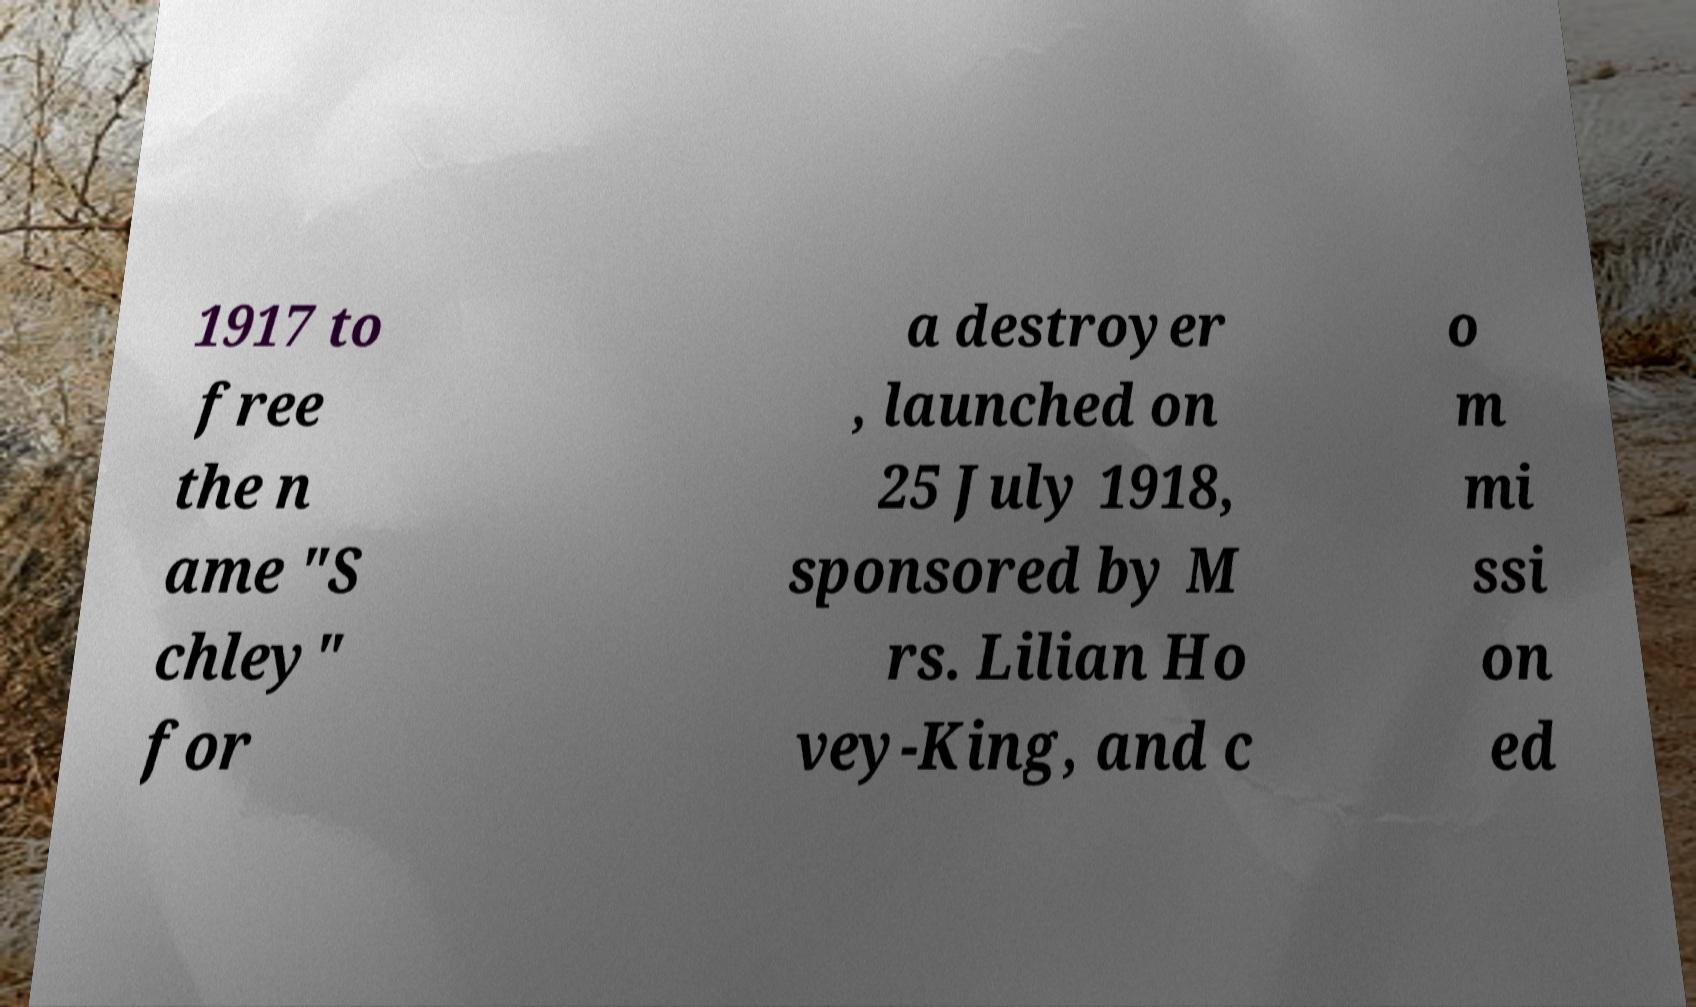Please read and relay the text visible in this image. What does it say? 1917 to free the n ame "S chley" for a destroyer , launched on 25 July 1918, sponsored by M rs. Lilian Ho vey-King, and c o m mi ssi on ed 